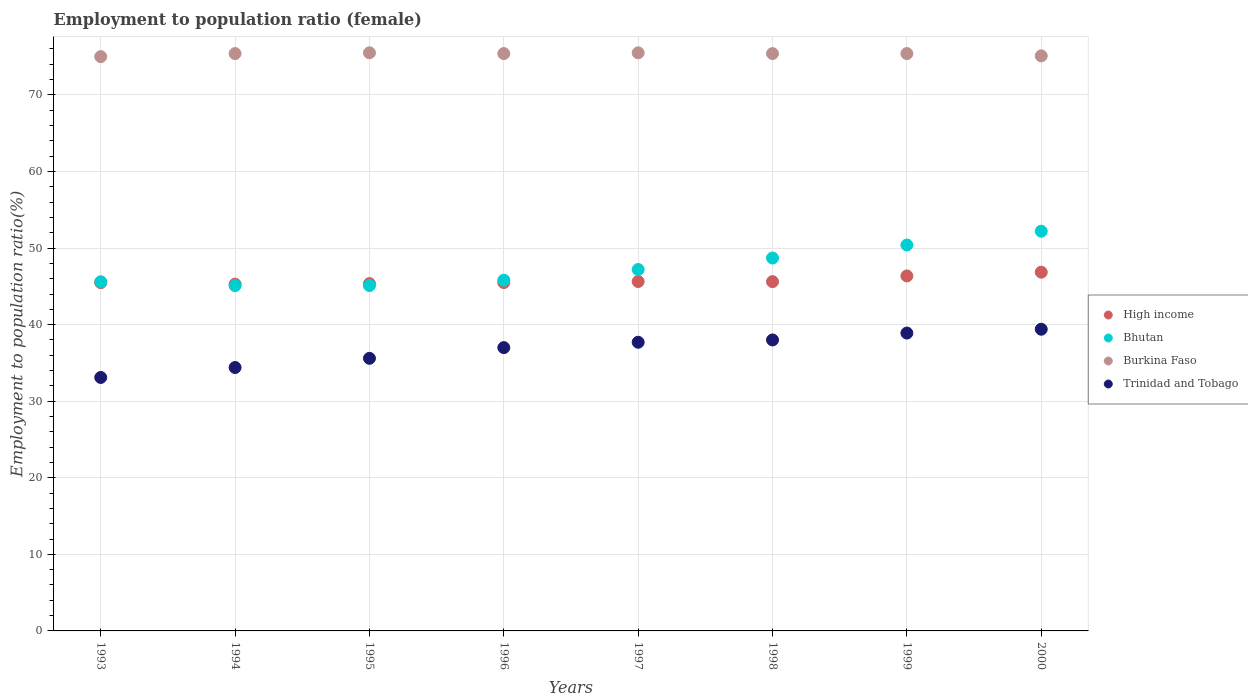Across all years, what is the maximum employment to population ratio in High income?
Give a very brief answer. 46.85. Across all years, what is the minimum employment to population ratio in Trinidad and Tobago?
Ensure brevity in your answer.  33.1. In which year was the employment to population ratio in Trinidad and Tobago maximum?
Provide a succinct answer. 2000. In which year was the employment to population ratio in Burkina Faso minimum?
Keep it short and to the point. 1993. What is the total employment to population ratio in Burkina Faso in the graph?
Offer a very short reply. 602.7. What is the difference between the employment to population ratio in Burkina Faso in 1998 and the employment to population ratio in Bhutan in 1996?
Your response must be concise. 29.6. What is the average employment to population ratio in High income per year?
Give a very brief answer. 45.76. In the year 1999, what is the difference between the employment to population ratio in Trinidad and Tobago and employment to population ratio in High income?
Your answer should be compact. -7.46. What is the ratio of the employment to population ratio in Trinidad and Tobago in 1996 to that in 2000?
Keep it short and to the point. 0.94. Is the employment to population ratio in Bhutan in 1994 less than that in 1998?
Keep it short and to the point. Yes. In how many years, is the employment to population ratio in High income greater than the average employment to population ratio in High income taken over all years?
Provide a succinct answer. 2. Is it the case that in every year, the sum of the employment to population ratio in High income and employment to population ratio in Burkina Faso  is greater than the employment to population ratio in Bhutan?
Give a very brief answer. Yes. Is the employment to population ratio in Bhutan strictly greater than the employment to population ratio in Burkina Faso over the years?
Give a very brief answer. No. How many years are there in the graph?
Provide a succinct answer. 8. Are the values on the major ticks of Y-axis written in scientific E-notation?
Your answer should be very brief. No. Does the graph contain grids?
Keep it short and to the point. Yes. Where does the legend appear in the graph?
Your answer should be compact. Center right. What is the title of the graph?
Your response must be concise. Employment to population ratio (female). Does "Switzerland" appear as one of the legend labels in the graph?
Ensure brevity in your answer.  No. What is the Employment to population ratio(%) in High income in 1993?
Your answer should be compact. 45.48. What is the Employment to population ratio(%) in Bhutan in 1993?
Keep it short and to the point. 45.6. What is the Employment to population ratio(%) in Trinidad and Tobago in 1993?
Ensure brevity in your answer.  33.1. What is the Employment to population ratio(%) in High income in 1994?
Ensure brevity in your answer.  45.29. What is the Employment to population ratio(%) of Bhutan in 1994?
Your answer should be very brief. 45.1. What is the Employment to population ratio(%) in Burkina Faso in 1994?
Offer a terse response. 75.4. What is the Employment to population ratio(%) of Trinidad and Tobago in 1994?
Give a very brief answer. 34.4. What is the Employment to population ratio(%) in High income in 1995?
Give a very brief answer. 45.36. What is the Employment to population ratio(%) of Bhutan in 1995?
Provide a succinct answer. 45.1. What is the Employment to population ratio(%) in Burkina Faso in 1995?
Make the answer very short. 75.5. What is the Employment to population ratio(%) of Trinidad and Tobago in 1995?
Ensure brevity in your answer.  35.6. What is the Employment to population ratio(%) of High income in 1996?
Your answer should be compact. 45.5. What is the Employment to population ratio(%) of Bhutan in 1996?
Your response must be concise. 45.8. What is the Employment to population ratio(%) of Burkina Faso in 1996?
Make the answer very short. 75.4. What is the Employment to population ratio(%) in Trinidad and Tobago in 1996?
Your response must be concise. 37. What is the Employment to population ratio(%) of High income in 1997?
Ensure brevity in your answer.  45.63. What is the Employment to population ratio(%) of Bhutan in 1997?
Your answer should be very brief. 47.2. What is the Employment to population ratio(%) of Burkina Faso in 1997?
Give a very brief answer. 75.5. What is the Employment to population ratio(%) in Trinidad and Tobago in 1997?
Provide a succinct answer. 37.7. What is the Employment to population ratio(%) of High income in 1998?
Keep it short and to the point. 45.61. What is the Employment to population ratio(%) in Bhutan in 1998?
Give a very brief answer. 48.7. What is the Employment to population ratio(%) of Burkina Faso in 1998?
Offer a terse response. 75.4. What is the Employment to population ratio(%) in Trinidad and Tobago in 1998?
Your answer should be very brief. 38. What is the Employment to population ratio(%) in High income in 1999?
Your response must be concise. 46.36. What is the Employment to population ratio(%) of Bhutan in 1999?
Make the answer very short. 50.4. What is the Employment to population ratio(%) of Burkina Faso in 1999?
Provide a succinct answer. 75.4. What is the Employment to population ratio(%) of Trinidad and Tobago in 1999?
Keep it short and to the point. 38.9. What is the Employment to population ratio(%) in High income in 2000?
Offer a very short reply. 46.85. What is the Employment to population ratio(%) in Bhutan in 2000?
Give a very brief answer. 52.2. What is the Employment to population ratio(%) of Burkina Faso in 2000?
Give a very brief answer. 75.1. What is the Employment to population ratio(%) of Trinidad and Tobago in 2000?
Offer a very short reply. 39.4. Across all years, what is the maximum Employment to population ratio(%) in High income?
Your answer should be very brief. 46.85. Across all years, what is the maximum Employment to population ratio(%) in Bhutan?
Offer a very short reply. 52.2. Across all years, what is the maximum Employment to population ratio(%) in Burkina Faso?
Keep it short and to the point. 75.5. Across all years, what is the maximum Employment to population ratio(%) of Trinidad and Tobago?
Your answer should be compact. 39.4. Across all years, what is the minimum Employment to population ratio(%) in High income?
Offer a terse response. 45.29. Across all years, what is the minimum Employment to population ratio(%) of Bhutan?
Your response must be concise. 45.1. Across all years, what is the minimum Employment to population ratio(%) of Trinidad and Tobago?
Ensure brevity in your answer.  33.1. What is the total Employment to population ratio(%) in High income in the graph?
Your answer should be very brief. 366.08. What is the total Employment to population ratio(%) of Bhutan in the graph?
Provide a short and direct response. 380.1. What is the total Employment to population ratio(%) of Burkina Faso in the graph?
Offer a terse response. 602.7. What is the total Employment to population ratio(%) in Trinidad and Tobago in the graph?
Provide a short and direct response. 294.1. What is the difference between the Employment to population ratio(%) of High income in 1993 and that in 1994?
Ensure brevity in your answer.  0.19. What is the difference between the Employment to population ratio(%) in Bhutan in 1993 and that in 1994?
Provide a succinct answer. 0.5. What is the difference between the Employment to population ratio(%) in Trinidad and Tobago in 1993 and that in 1994?
Offer a terse response. -1.3. What is the difference between the Employment to population ratio(%) of High income in 1993 and that in 1995?
Make the answer very short. 0.12. What is the difference between the Employment to population ratio(%) of Bhutan in 1993 and that in 1995?
Offer a terse response. 0.5. What is the difference between the Employment to population ratio(%) of High income in 1993 and that in 1996?
Give a very brief answer. -0.01. What is the difference between the Employment to population ratio(%) of Bhutan in 1993 and that in 1996?
Give a very brief answer. -0.2. What is the difference between the Employment to population ratio(%) of Burkina Faso in 1993 and that in 1996?
Provide a short and direct response. -0.4. What is the difference between the Employment to population ratio(%) in Trinidad and Tobago in 1993 and that in 1996?
Make the answer very short. -3.9. What is the difference between the Employment to population ratio(%) in High income in 1993 and that in 1997?
Keep it short and to the point. -0.15. What is the difference between the Employment to population ratio(%) in Burkina Faso in 1993 and that in 1997?
Ensure brevity in your answer.  -0.5. What is the difference between the Employment to population ratio(%) of Trinidad and Tobago in 1993 and that in 1997?
Keep it short and to the point. -4.6. What is the difference between the Employment to population ratio(%) of High income in 1993 and that in 1998?
Keep it short and to the point. -0.13. What is the difference between the Employment to population ratio(%) of Bhutan in 1993 and that in 1998?
Ensure brevity in your answer.  -3.1. What is the difference between the Employment to population ratio(%) of High income in 1993 and that in 1999?
Ensure brevity in your answer.  -0.88. What is the difference between the Employment to population ratio(%) in Bhutan in 1993 and that in 1999?
Provide a short and direct response. -4.8. What is the difference between the Employment to population ratio(%) in Trinidad and Tobago in 1993 and that in 1999?
Offer a very short reply. -5.8. What is the difference between the Employment to population ratio(%) in High income in 1993 and that in 2000?
Your answer should be very brief. -1.37. What is the difference between the Employment to population ratio(%) of Trinidad and Tobago in 1993 and that in 2000?
Your answer should be very brief. -6.3. What is the difference between the Employment to population ratio(%) of High income in 1994 and that in 1995?
Ensure brevity in your answer.  -0.07. What is the difference between the Employment to population ratio(%) of Bhutan in 1994 and that in 1995?
Keep it short and to the point. 0. What is the difference between the Employment to population ratio(%) of High income in 1994 and that in 1996?
Give a very brief answer. -0.2. What is the difference between the Employment to population ratio(%) of Bhutan in 1994 and that in 1996?
Keep it short and to the point. -0.7. What is the difference between the Employment to population ratio(%) of High income in 1994 and that in 1997?
Give a very brief answer. -0.34. What is the difference between the Employment to population ratio(%) in Burkina Faso in 1994 and that in 1997?
Make the answer very short. -0.1. What is the difference between the Employment to population ratio(%) of High income in 1994 and that in 1998?
Your response must be concise. -0.32. What is the difference between the Employment to population ratio(%) in Burkina Faso in 1994 and that in 1998?
Your answer should be very brief. 0. What is the difference between the Employment to population ratio(%) of Trinidad and Tobago in 1994 and that in 1998?
Your response must be concise. -3.6. What is the difference between the Employment to population ratio(%) of High income in 1994 and that in 1999?
Provide a short and direct response. -1.07. What is the difference between the Employment to population ratio(%) of Burkina Faso in 1994 and that in 1999?
Your response must be concise. 0. What is the difference between the Employment to population ratio(%) in Trinidad and Tobago in 1994 and that in 1999?
Give a very brief answer. -4.5. What is the difference between the Employment to population ratio(%) in High income in 1994 and that in 2000?
Make the answer very short. -1.56. What is the difference between the Employment to population ratio(%) of Bhutan in 1994 and that in 2000?
Offer a terse response. -7.1. What is the difference between the Employment to population ratio(%) in Burkina Faso in 1994 and that in 2000?
Make the answer very short. 0.3. What is the difference between the Employment to population ratio(%) in Trinidad and Tobago in 1994 and that in 2000?
Ensure brevity in your answer.  -5. What is the difference between the Employment to population ratio(%) in High income in 1995 and that in 1996?
Provide a succinct answer. -0.14. What is the difference between the Employment to population ratio(%) in High income in 1995 and that in 1997?
Your answer should be very brief. -0.27. What is the difference between the Employment to population ratio(%) in Burkina Faso in 1995 and that in 1997?
Keep it short and to the point. 0. What is the difference between the Employment to population ratio(%) in High income in 1995 and that in 1998?
Provide a succinct answer. -0.25. What is the difference between the Employment to population ratio(%) in Bhutan in 1995 and that in 1998?
Keep it short and to the point. -3.6. What is the difference between the Employment to population ratio(%) of Trinidad and Tobago in 1995 and that in 1998?
Keep it short and to the point. -2.4. What is the difference between the Employment to population ratio(%) in High income in 1995 and that in 1999?
Offer a very short reply. -1. What is the difference between the Employment to population ratio(%) of Burkina Faso in 1995 and that in 1999?
Your response must be concise. 0.1. What is the difference between the Employment to population ratio(%) in High income in 1995 and that in 2000?
Keep it short and to the point. -1.49. What is the difference between the Employment to population ratio(%) of Burkina Faso in 1995 and that in 2000?
Ensure brevity in your answer.  0.4. What is the difference between the Employment to population ratio(%) of High income in 1996 and that in 1997?
Give a very brief answer. -0.14. What is the difference between the Employment to population ratio(%) in Burkina Faso in 1996 and that in 1997?
Provide a succinct answer. -0.1. What is the difference between the Employment to population ratio(%) of Trinidad and Tobago in 1996 and that in 1997?
Keep it short and to the point. -0.7. What is the difference between the Employment to population ratio(%) in High income in 1996 and that in 1998?
Offer a very short reply. -0.12. What is the difference between the Employment to population ratio(%) in Trinidad and Tobago in 1996 and that in 1998?
Make the answer very short. -1. What is the difference between the Employment to population ratio(%) of High income in 1996 and that in 1999?
Your response must be concise. -0.86. What is the difference between the Employment to population ratio(%) in Trinidad and Tobago in 1996 and that in 1999?
Your answer should be compact. -1.9. What is the difference between the Employment to population ratio(%) in High income in 1996 and that in 2000?
Your answer should be very brief. -1.36. What is the difference between the Employment to population ratio(%) of Burkina Faso in 1996 and that in 2000?
Make the answer very short. 0.3. What is the difference between the Employment to population ratio(%) in Trinidad and Tobago in 1996 and that in 2000?
Give a very brief answer. -2.4. What is the difference between the Employment to population ratio(%) in High income in 1997 and that in 1998?
Ensure brevity in your answer.  0.02. What is the difference between the Employment to population ratio(%) in High income in 1997 and that in 1999?
Keep it short and to the point. -0.73. What is the difference between the Employment to population ratio(%) of High income in 1997 and that in 2000?
Keep it short and to the point. -1.22. What is the difference between the Employment to population ratio(%) in High income in 1998 and that in 1999?
Make the answer very short. -0.75. What is the difference between the Employment to population ratio(%) of Bhutan in 1998 and that in 1999?
Ensure brevity in your answer.  -1.7. What is the difference between the Employment to population ratio(%) in High income in 1998 and that in 2000?
Offer a terse response. -1.24. What is the difference between the Employment to population ratio(%) in High income in 1999 and that in 2000?
Make the answer very short. -0.49. What is the difference between the Employment to population ratio(%) of Bhutan in 1999 and that in 2000?
Keep it short and to the point. -1.8. What is the difference between the Employment to population ratio(%) of Burkina Faso in 1999 and that in 2000?
Keep it short and to the point. 0.3. What is the difference between the Employment to population ratio(%) of Trinidad and Tobago in 1999 and that in 2000?
Provide a succinct answer. -0.5. What is the difference between the Employment to population ratio(%) in High income in 1993 and the Employment to population ratio(%) in Bhutan in 1994?
Provide a short and direct response. 0.38. What is the difference between the Employment to population ratio(%) in High income in 1993 and the Employment to population ratio(%) in Burkina Faso in 1994?
Provide a short and direct response. -29.92. What is the difference between the Employment to population ratio(%) in High income in 1993 and the Employment to population ratio(%) in Trinidad and Tobago in 1994?
Your answer should be very brief. 11.08. What is the difference between the Employment to population ratio(%) in Bhutan in 1993 and the Employment to population ratio(%) in Burkina Faso in 1994?
Give a very brief answer. -29.8. What is the difference between the Employment to population ratio(%) in Burkina Faso in 1993 and the Employment to population ratio(%) in Trinidad and Tobago in 1994?
Provide a succinct answer. 40.6. What is the difference between the Employment to population ratio(%) of High income in 1993 and the Employment to population ratio(%) of Bhutan in 1995?
Offer a very short reply. 0.38. What is the difference between the Employment to population ratio(%) of High income in 1993 and the Employment to population ratio(%) of Burkina Faso in 1995?
Keep it short and to the point. -30.02. What is the difference between the Employment to population ratio(%) in High income in 1993 and the Employment to population ratio(%) in Trinidad and Tobago in 1995?
Provide a succinct answer. 9.88. What is the difference between the Employment to population ratio(%) of Bhutan in 1993 and the Employment to population ratio(%) of Burkina Faso in 1995?
Keep it short and to the point. -29.9. What is the difference between the Employment to population ratio(%) of Bhutan in 1993 and the Employment to population ratio(%) of Trinidad and Tobago in 1995?
Your response must be concise. 10. What is the difference between the Employment to population ratio(%) of Burkina Faso in 1993 and the Employment to population ratio(%) of Trinidad and Tobago in 1995?
Your answer should be compact. 39.4. What is the difference between the Employment to population ratio(%) in High income in 1993 and the Employment to population ratio(%) in Bhutan in 1996?
Your response must be concise. -0.32. What is the difference between the Employment to population ratio(%) in High income in 1993 and the Employment to population ratio(%) in Burkina Faso in 1996?
Your answer should be compact. -29.92. What is the difference between the Employment to population ratio(%) in High income in 1993 and the Employment to population ratio(%) in Trinidad and Tobago in 1996?
Keep it short and to the point. 8.48. What is the difference between the Employment to population ratio(%) of Bhutan in 1993 and the Employment to population ratio(%) of Burkina Faso in 1996?
Give a very brief answer. -29.8. What is the difference between the Employment to population ratio(%) in Bhutan in 1993 and the Employment to population ratio(%) in Trinidad and Tobago in 1996?
Give a very brief answer. 8.6. What is the difference between the Employment to population ratio(%) in Burkina Faso in 1993 and the Employment to population ratio(%) in Trinidad and Tobago in 1996?
Ensure brevity in your answer.  38. What is the difference between the Employment to population ratio(%) of High income in 1993 and the Employment to population ratio(%) of Bhutan in 1997?
Offer a very short reply. -1.72. What is the difference between the Employment to population ratio(%) in High income in 1993 and the Employment to population ratio(%) in Burkina Faso in 1997?
Your answer should be very brief. -30.02. What is the difference between the Employment to population ratio(%) in High income in 1993 and the Employment to population ratio(%) in Trinidad and Tobago in 1997?
Provide a short and direct response. 7.78. What is the difference between the Employment to population ratio(%) in Bhutan in 1993 and the Employment to population ratio(%) in Burkina Faso in 1997?
Your answer should be very brief. -29.9. What is the difference between the Employment to population ratio(%) of Burkina Faso in 1993 and the Employment to population ratio(%) of Trinidad and Tobago in 1997?
Your answer should be very brief. 37.3. What is the difference between the Employment to population ratio(%) of High income in 1993 and the Employment to population ratio(%) of Bhutan in 1998?
Provide a succinct answer. -3.22. What is the difference between the Employment to population ratio(%) in High income in 1993 and the Employment to population ratio(%) in Burkina Faso in 1998?
Give a very brief answer. -29.92. What is the difference between the Employment to population ratio(%) of High income in 1993 and the Employment to population ratio(%) of Trinidad and Tobago in 1998?
Ensure brevity in your answer.  7.48. What is the difference between the Employment to population ratio(%) in Bhutan in 1993 and the Employment to population ratio(%) in Burkina Faso in 1998?
Your answer should be very brief. -29.8. What is the difference between the Employment to population ratio(%) in High income in 1993 and the Employment to population ratio(%) in Bhutan in 1999?
Keep it short and to the point. -4.92. What is the difference between the Employment to population ratio(%) in High income in 1993 and the Employment to population ratio(%) in Burkina Faso in 1999?
Give a very brief answer. -29.92. What is the difference between the Employment to population ratio(%) in High income in 1993 and the Employment to population ratio(%) in Trinidad and Tobago in 1999?
Your response must be concise. 6.58. What is the difference between the Employment to population ratio(%) of Bhutan in 1993 and the Employment to population ratio(%) of Burkina Faso in 1999?
Give a very brief answer. -29.8. What is the difference between the Employment to population ratio(%) of Burkina Faso in 1993 and the Employment to population ratio(%) of Trinidad and Tobago in 1999?
Keep it short and to the point. 36.1. What is the difference between the Employment to population ratio(%) of High income in 1993 and the Employment to population ratio(%) of Bhutan in 2000?
Provide a short and direct response. -6.72. What is the difference between the Employment to population ratio(%) in High income in 1993 and the Employment to population ratio(%) in Burkina Faso in 2000?
Keep it short and to the point. -29.62. What is the difference between the Employment to population ratio(%) in High income in 1993 and the Employment to population ratio(%) in Trinidad and Tobago in 2000?
Your answer should be very brief. 6.08. What is the difference between the Employment to population ratio(%) of Bhutan in 1993 and the Employment to population ratio(%) of Burkina Faso in 2000?
Provide a succinct answer. -29.5. What is the difference between the Employment to population ratio(%) of Bhutan in 1993 and the Employment to population ratio(%) of Trinidad and Tobago in 2000?
Provide a succinct answer. 6.2. What is the difference between the Employment to population ratio(%) in Burkina Faso in 1993 and the Employment to population ratio(%) in Trinidad and Tobago in 2000?
Ensure brevity in your answer.  35.6. What is the difference between the Employment to population ratio(%) in High income in 1994 and the Employment to population ratio(%) in Bhutan in 1995?
Your response must be concise. 0.19. What is the difference between the Employment to population ratio(%) in High income in 1994 and the Employment to population ratio(%) in Burkina Faso in 1995?
Make the answer very short. -30.21. What is the difference between the Employment to population ratio(%) in High income in 1994 and the Employment to population ratio(%) in Trinidad and Tobago in 1995?
Offer a very short reply. 9.69. What is the difference between the Employment to population ratio(%) of Bhutan in 1994 and the Employment to population ratio(%) of Burkina Faso in 1995?
Give a very brief answer. -30.4. What is the difference between the Employment to population ratio(%) in Bhutan in 1994 and the Employment to population ratio(%) in Trinidad and Tobago in 1995?
Your response must be concise. 9.5. What is the difference between the Employment to population ratio(%) in Burkina Faso in 1994 and the Employment to population ratio(%) in Trinidad and Tobago in 1995?
Give a very brief answer. 39.8. What is the difference between the Employment to population ratio(%) of High income in 1994 and the Employment to population ratio(%) of Bhutan in 1996?
Ensure brevity in your answer.  -0.51. What is the difference between the Employment to population ratio(%) in High income in 1994 and the Employment to population ratio(%) in Burkina Faso in 1996?
Your response must be concise. -30.11. What is the difference between the Employment to population ratio(%) of High income in 1994 and the Employment to population ratio(%) of Trinidad and Tobago in 1996?
Ensure brevity in your answer.  8.29. What is the difference between the Employment to population ratio(%) in Bhutan in 1994 and the Employment to population ratio(%) in Burkina Faso in 1996?
Provide a succinct answer. -30.3. What is the difference between the Employment to population ratio(%) in Burkina Faso in 1994 and the Employment to population ratio(%) in Trinidad and Tobago in 1996?
Offer a terse response. 38.4. What is the difference between the Employment to population ratio(%) in High income in 1994 and the Employment to population ratio(%) in Bhutan in 1997?
Ensure brevity in your answer.  -1.91. What is the difference between the Employment to population ratio(%) of High income in 1994 and the Employment to population ratio(%) of Burkina Faso in 1997?
Ensure brevity in your answer.  -30.21. What is the difference between the Employment to population ratio(%) in High income in 1994 and the Employment to population ratio(%) in Trinidad and Tobago in 1997?
Provide a short and direct response. 7.59. What is the difference between the Employment to population ratio(%) in Bhutan in 1994 and the Employment to population ratio(%) in Burkina Faso in 1997?
Keep it short and to the point. -30.4. What is the difference between the Employment to population ratio(%) of Bhutan in 1994 and the Employment to population ratio(%) of Trinidad and Tobago in 1997?
Offer a terse response. 7.4. What is the difference between the Employment to population ratio(%) in Burkina Faso in 1994 and the Employment to population ratio(%) in Trinidad and Tobago in 1997?
Give a very brief answer. 37.7. What is the difference between the Employment to population ratio(%) in High income in 1994 and the Employment to population ratio(%) in Bhutan in 1998?
Your response must be concise. -3.41. What is the difference between the Employment to population ratio(%) of High income in 1994 and the Employment to population ratio(%) of Burkina Faso in 1998?
Offer a terse response. -30.11. What is the difference between the Employment to population ratio(%) of High income in 1994 and the Employment to population ratio(%) of Trinidad and Tobago in 1998?
Make the answer very short. 7.29. What is the difference between the Employment to population ratio(%) in Bhutan in 1994 and the Employment to population ratio(%) in Burkina Faso in 1998?
Keep it short and to the point. -30.3. What is the difference between the Employment to population ratio(%) in Burkina Faso in 1994 and the Employment to population ratio(%) in Trinidad and Tobago in 1998?
Your answer should be compact. 37.4. What is the difference between the Employment to population ratio(%) in High income in 1994 and the Employment to population ratio(%) in Bhutan in 1999?
Provide a succinct answer. -5.11. What is the difference between the Employment to population ratio(%) of High income in 1994 and the Employment to population ratio(%) of Burkina Faso in 1999?
Your answer should be compact. -30.11. What is the difference between the Employment to population ratio(%) in High income in 1994 and the Employment to population ratio(%) in Trinidad and Tobago in 1999?
Give a very brief answer. 6.39. What is the difference between the Employment to population ratio(%) of Bhutan in 1994 and the Employment to population ratio(%) of Burkina Faso in 1999?
Provide a short and direct response. -30.3. What is the difference between the Employment to population ratio(%) of Burkina Faso in 1994 and the Employment to population ratio(%) of Trinidad and Tobago in 1999?
Provide a succinct answer. 36.5. What is the difference between the Employment to population ratio(%) in High income in 1994 and the Employment to population ratio(%) in Bhutan in 2000?
Your response must be concise. -6.91. What is the difference between the Employment to population ratio(%) of High income in 1994 and the Employment to population ratio(%) of Burkina Faso in 2000?
Ensure brevity in your answer.  -29.81. What is the difference between the Employment to population ratio(%) in High income in 1994 and the Employment to population ratio(%) in Trinidad and Tobago in 2000?
Your response must be concise. 5.89. What is the difference between the Employment to population ratio(%) in Bhutan in 1994 and the Employment to population ratio(%) in Trinidad and Tobago in 2000?
Keep it short and to the point. 5.7. What is the difference between the Employment to population ratio(%) of Burkina Faso in 1994 and the Employment to population ratio(%) of Trinidad and Tobago in 2000?
Provide a short and direct response. 36. What is the difference between the Employment to population ratio(%) of High income in 1995 and the Employment to population ratio(%) of Bhutan in 1996?
Provide a short and direct response. -0.44. What is the difference between the Employment to population ratio(%) in High income in 1995 and the Employment to population ratio(%) in Burkina Faso in 1996?
Offer a very short reply. -30.04. What is the difference between the Employment to population ratio(%) of High income in 1995 and the Employment to population ratio(%) of Trinidad and Tobago in 1996?
Ensure brevity in your answer.  8.36. What is the difference between the Employment to population ratio(%) in Bhutan in 1995 and the Employment to population ratio(%) in Burkina Faso in 1996?
Your answer should be very brief. -30.3. What is the difference between the Employment to population ratio(%) of Bhutan in 1995 and the Employment to population ratio(%) of Trinidad and Tobago in 1996?
Ensure brevity in your answer.  8.1. What is the difference between the Employment to population ratio(%) in Burkina Faso in 1995 and the Employment to population ratio(%) in Trinidad and Tobago in 1996?
Your answer should be compact. 38.5. What is the difference between the Employment to population ratio(%) of High income in 1995 and the Employment to population ratio(%) of Bhutan in 1997?
Your answer should be compact. -1.84. What is the difference between the Employment to population ratio(%) of High income in 1995 and the Employment to population ratio(%) of Burkina Faso in 1997?
Make the answer very short. -30.14. What is the difference between the Employment to population ratio(%) of High income in 1995 and the Employment to population ratio(%) of Trinidad and Tobago in 1997?
Keep it short and to the point. 7.66. What is the difference between the Employment to population ratio(%) in Bhutan in 1995 and the Employment to population ratio(%) in Burkina Faso in 1997?
Keep it short and to the point. -30.4. What is the difference between the Employment to population ratio(%) in Burkina Faso in 1995 and the Employment to population ratio(%) in Trinidad and Tobago in 1997?
Give a very brief answer. 37.8. What is the difference between the Employment to population ratio(%) of High income in 1995 and the Employment to population ratio(%) of Bhutan in 1998?
Provide a short and direct response. -3.34. What is the difference between the Employment to population ratio(%) in High income in 1995 and the Employment to population ratio(%) in Burkina Faso in 1998?
Offer a terse response. -30.04. What is the difference between the Employment to population ratio(%) in High income in 1995 and the Employment to population ratio(%) in Trinidad and Tobago in 1998?
Offer a very short reply. 7.36. What is the difference between the Employment to population ratio(%) in Bhutan in 1995 and the Employment to population ratio(%) in Burkina Faso in 1998?
Your answer should be compact. -30.3. What is the difference between the Employment to population ratio(%) of Burkina Faso in 1995 and the Employment to population ratio(%) of Trinidad and Tobago in 1998?
Your answer should be very brief. 37.5. What is the difference between the Employment to population ratio(%) of High income in 1995 and the Employment to population ratio(%) of Bhutan in 1999?
Give a very brief answer. -5.04. What is the difference between the Employment to population ratio(%) of High income in 1995 and the Employment to population ratio(%) of Burkina Faso in 1999?
Provide a short and direct response. -30.04. What is the difference between the Employment to population ratio(%) of High income in 1995 and the Employment to population ratio(%) of Trinidad and Tobago in 1999?
Offer a terse response. 6.46. What is the difference between the Employment to population ratio(%) of Bhutan in 1995 and the Employment to population ratio(%) of Burkina Faso in 1999?
Your answer should be very brief. -30.3. What is the difference between the Employment to population ratio(%) of Burkina Faso in 1995 and the Employment to population ratio(%) of Trinidad and Tobago in 1999?
Provide a succinct answer. 36.6. What is the difference between the Employment to population ratio(%) of High income in 1995 and the Employment to population ratio(%) of Bhutan in 2000?
Keep it short and to the point. -6.84. What is the difference between the Employment to population ratio(%) in High income in 1995 and the Employment to population ratio(%) in Burkina Faso in 2000?
Your answer should be very brief. -29.74. What is the difference between the Employment to population ratio(%) of High income in 1995 and the Employment to population ratio(%) of Trinidad and Tobago in 2000?
Ensure brevity in your answer.  5.96. What is the difference between the Employment to population ratio(%) of Burkina Faso in 1995 and the Employment to population ratio(%) of Trinidad and Tobago in 2000?
Your answer should be very brief. 36.1. What is the difference between the Employment to population ratio(%) of High income in 1996 and the Employment to population ratio(%) of Bhutan in 1997?
Your answer should be compact. -1.7. What is the difference between the Employment to population ratio(%) of High income in 1996 and the Employment to population ratio(%) of Burkina Faso in 1997?
Your answer should be compact. -30. What is the difference between the Employment to population ratio(%) in High income in 1996 and the Employment to population ratio(%) in Trinidad and Tobago in 1997?
Make the answer very short. 7.8. What is the difference between the Employment to population ratio(%) of Bhutan in 1996 and the Employment to population ratio(%) of Burkina Faso in 1997?
Give a very brief answer. -29.7. What is the difference between the Employment to population ratio(%) in Bhutan in 1996 and the Employment to population ratio(%) in Trinidad and Tobago in 1997?
Make the answer very short. 8.1. What is the difference between the Employment to population ratio(%) in Burkina Faso in 1996 and the Employment to population ratio(%) in Trinidad and Tobago in 1997?
Your response must be concise. 37.7. What is the difference between the Employment to population ratio(%) in High income in 1996 and the Employment to population ratio(%) in Bhutan in 1998?
Your response must be concise. -3.2. What is the difference between the Employment to population ratio(%) in High income in 1996 and the Employment to population ratio(%) in Burkina Faso in 1998?
Your answer should be very brief. -29.9. What is the difference between the Employment to population ratio(%) in High income in 1996 and the Employment to population ratio(%) in Trinidad and Tobago in 1998?
Offer a terse response. 7.5. What is the difference between the Employment to population ratio(%) in Bhutan in 1996 and the Employment to population ratio(%) in Burkina Faso in 1998?
Provide a short and direct response. -29.6. What is the difference between the Employment to population ratio(%) in Burkina Faso in 1996 and the Employment to population ratio(%) in Trinidad and Tobago in 1998?
Provide a short and direct response. 37.4. What is the difference between the Employment to population ratio(%) in High income in 1996 and the Employment to population ratio(%) in Bhutan in 1999?
Make the answer very short. -4.9. What is the difference between the Employment to population ratio(%) of High income in 1996 and the Employment to population ratio(%) of Burkina Faso in 1999?
Make the answer very short. -29.9. What is the difference between the Employment to population ratio(%) of High income in 1996 and the Employment to population ratio(%) of Trinidad and Tobago in 1999?
Your response must be concise. 6.6. What is the difference between the Employment to population ratio(%) in Bhutan in 1996 and the Employment to population ratio(%) in Burkina Faso in 1999?
Provide a short and direct response. -29.6. What is the difference between the Employment to population ratio(%) in Burkina Faso in 1996 and the Employment to population ratio(%) in Trinidad and Tobago in 1999?
Provide a succinct answer. 36.5. What is the difference between the Employment to population ratio(%) of High income in 1996 and the Employment to population ratio(%) of Bhutan in 2000?
Your answer should be very brief. -6.7. What is the difference between the Employment to population ratio(%) of High income in 1996 and the Employment to population ratio(%) of Burkina Faso in 2000?
Make the answer very short. -29.6. What is the difference between the Employment to population ratio(%) of High income in 1996 and the Employment to population ratio(%) of Trinidad and Tobago in 2000?
Provide a succinct answer. 6.1. What is the difference between the Employment to population ratio(%) of Bhutan in 1996 and the Employment to population ratio(%) of Burkina Faso in 2000?
Give a very brief answer. -29.3. What is the difference between the Employment to population ratio(%) in Bhutan in 1996 and the Employment to population ratio(%) in Trinidad and Tobago in 2000?
Your answer should be compact. 6.4. What is the difference between the Employment to population ratio(%) in High income in 1997 and the Employment to population ratio(%) in Bhutan in 1998?
Ensure brevity in your answer.  -3.07. What is the difference between the Employment to population ratio(%) in High income in 1997 and the Employment to population ratio(%) in Burkina Faso in 1998?
Provide a succinct answer. -29.77. What is the difference between the Employment to population ratio(%) in High income in 1997 and the Employment to population ratio(%) in Trinidad and Tobago in 1998?
Provide a short and direct response. 7.63. What is the difference between the Employment to population ratio(%) in Bhutan in 1997 and the Employment to population ratio(%) in Burkina Faso in 1998?
Your response must be concise. -28.2. What is the difference between the Employment to population ratio(%) in Burkina Faso in 1997 and the Employment to population ratio(%) in Trinidad and Tobago in 1998?
Make the answer very short. 37.5. What is the difference between the Employment to population ratio(%) of High income in 1997 and the Employment to population ratio(%) of Bhutan in 1999?
Your answer should be very brief. -4.77. What is the difference between the Employment to population ratio(%) in High income in 1997 and the Employment to population ratio(%) in Burkina Faso in 1999?
Your answer should be compact. -29.77. What is the difference between the Employment to population ratio(%) in High income in 1997 and the Employment to population ratio(%) in Trinidad and Tobago in 1999?
Your response must be concise. 6.73. What is the difference between the Employment to population ratio(%) of Bhutan in 1997 and the Employment to population ratio(%) of Burkina Faso in 1999?
Provide a succinct answer. -28.2. What is the difference between the Employment to population ratio(%) of Bhutan in 1997 and the Employment to population ratio(%) of Trinidad and Tobago in 1999?
Your answer should be very brief. 8.3. What is the difference between the Employment to population ratio(%) in Burkina Faso in 1997 and the Employment to population ratio(%) in Trinidad and Tobago in 1999?
Your response must be concise. 36.6. What is the difference between the Employment to population ratio(%) in High income in 1997 and the Employment to population ratio(%) in Bhutan in 2000?
Your answer should be compact. -6.57. What is the difference between the Employment to population ratio(%) of High income in 1997 and the Employment to population ratio(%) of Burkina Faso in 2000?
Give a very brief answer. -29.47. What is the difference between the Employment to population ratio(%) of High income in 1997 and the Employment to population ratio(%) of Trinidad and Tobago in 2000?
Ensure brevity in your answer.  6.23. What is the difference between the Employment to population ratio(%) in Bhutan in 1997 and the Employment to population ratio(%) in Burkina Faso in 2000?
Offer a terse response. -27.9. What is the difference between the Employment to population ratio(%) of Burkina Faso in 1997 and the Employment to population ratio(%) of Trinidad and Tobago in 2000?
Give a very brief answer. 36.1. What is the difference between the Employment to population ratio(%) in High income in 1998 and the Employment to population ratio(%) in Bhutan in 1999?
Your response must be concise. -4.79. What is the difference between the Employment to population ratio(%) of High income in 1998 and the Employment to population ratio(%) of Burkina Faso in 1999?
Keep it short and to the point. -29.79. What is the difference between the Employment to population ratio(%) in High income in 1998 and the Employment to population ratio(%) in Trinidad and Tobago in 1999?
Your response must be concise. 6.71. What is the difference between the Employment to population ratio(%) in Bhutan in 1998 and the Employment to population ratio(%) in Burkina Faso in 1999?
Your answer should be very brief. -26.7. What is the difference between the Employment to population ratio(%) in Burkina Faso in 1998 and the Employment to population ratio(%) in Trinidad and Tobago in 1999?
Your answer should be compact. 36.5. What is the difference between the Employment to population ratio(%) of High income in 1998 and the Employment to population ratio(%) of Bhutan in 2000?
Provide a short and direct response. -6.59. What is the difference between the Employment to population ratio(%) of High income in 1998 and the Employment to population ratio(%) of Burkina Faso in 2000?
Ensure brevity in your answer.  -29.49. What is the difference between the Employment to population ratio(%) of High income in 1998 and the Employment to population ratio(%) of Trinidad and Tobago in 2000?
Keep it short and to the point. 6.21. What is the difference between the Employment to population ratio(%) of Bhutan in 1998 and the Employment to population ratio(%) of Burkina Faso in 2000?
Your response must be concise. -26.4. What is the difference between the Employment to population ratio(%) in High income in 1999 and the Employment to population ratio(%) in Bhutan in 2000?
Offer a terse response. -5.84. What is the difference between the Employment to population ratio(%) of High income in 1999 and the Employment to population ratio(%) of Burkina Faso in 2000?
Give a very brief answer. -28.74. What is the difference between the Employment to population ratio(%) in High income in 1999 and the Employment to population ratio(%) in Trinidad and Tobago in 2000?
Keep it short and to the point. 6.96. What is the difference between the Employment to population ratio(%) in Bhutan in 1999 and the Employment to population ratio(%) in Burkina Faso in 2000?
Your answer should be very brief. -24.7. What is the difference between the Employment to population ratio(%) of Bhutan in 1999 and the Employment to population ratio(%) of Trinidad and Tobago in 2000?
Give a very brief answer. 11. What is the difference between the Employment to population ratio(%) in Burkina Faso in 1999 and the Employment to population ratio(%) in Trinidad and Tobago in 2000?
Offer a very short reply. 36. What is the average Employment to population ratio(%) of High income per year?
Your answer should be compact. 45.76. What is the average Employment to population ratio(%) of Bhutan per year?
Keep it short and to the point. 47.51. What is the average Employment to population ratio(%) of Burkina Faso per year?
Provide a succinct answer. 75.34. What is the average Employment to population ratio(%) of Trinidad and Tobago per year?
Offer a very short reply. 36.76. In the year 1993, what is the difference between the Employment to population ratio(%) of High income and Employment to population ratio(%) of Bhutan?
Provide a short and direct response. -0.12. In the year 1993, what is the difference between the Employment to population ratio(%) in High income and Employment to population ratio(%) in Burkina Faso?
Ensure brevity in your answer.  -29.52. In the year 1993, what is the difference between the Employment to population ratio(%) in High income and Employment to population ratio(%) in Trinidad and Tobago?
Your answer should be very brief. 12.38. In the year 1993, what is the difference between the Employment to population ratio(%) of Bhutan and Employment to population ratio(%) of Burkina Faso?
Your answer should be compact. -29.4. In the year 1993, what is the difference between the Employment to population ratio(%) of Burkina Faso and Employment to population ratio(%) of Trinidad and Tobago?
Give a very brief answer. 41.9. In the year 1994, what is the difference between the Employment to population ratio(%) of High income and Employment to population ratio(%) of Bhutan?
Offer a very short reply. 0.19. In the year 1994, what is the difference between the Employment to population ratio(%) of High income and Employment to population ratio(%) of Burkina Faso?
Your answer should be compact. -30.11. In the year 1994, what is the difference between the Employment to population ratio(%) in High income and Employment to population ratio(%) in Trinidad and Tobago?
Your response must be concise. 10.89. In the year 1994, what is the difference between the Employment to population ratio(%) in Bhutan and Employment to population ratio(%) in Burkina Faso?
Offer a very short reply. -30.3. In the year 1994, what is the difference between the Employment to population ratio(%) in Bhutan and Employment to population ratio(%) in Trinidad and Tobago?
Keep it short and to the point. 10.7. In the year 1994, what is the difference between the Employment to population ratio(%) in Burkina Faso and Employment to population ratio(%) in Trinidad and Tobago?
Make the answer very short. 41. In the year 1995, what is the difference between the Employment to population ratio(%) in High income and Employment to population ratio(%) in Bhutan?
Your answer should be compact. 0.26. In the year 1995, what is the difference between the Employment to population ratio(%) in High income and Employment to population ratio(%) in Burkina Faso?
Your answer should be compact. -30.14. In the year 1995, what is the difference between the Employment to population ratio(%) in High income and Employment to population ratio(%) in Trinidad and Tobago?
Provide a succinct answer. 9.76. In the year 1995, what is the difference between the Employment to population ratio(%) of Bhutan and Employment to population ratio(%) of Burkina Faso?
Keep it short and to the point. -30.4. In the year 1995, what is the difference between the Employment to population ratio(%) of Bhutan and Employment to population ratio(%) of Trinidad and Tobago?
Ensure brevity in your answer.  9.5. In the year 1995, what is the difference between the Employment to population ratio(%) in Burkina Faso and Employment to population ratio(%) in Trinidad and Tobago?
Provide a succinct answer. 39.9. In the year 1996, what is the difference between the Employment to population ratio(%) of High income and Employment to population ratio(%) of Bhutan?
Your response must be concise. -0.3. In the year 1996, what is the difference between the Employment to population ratio(%) in High income and Employment to population ratio(%) in Burkina Faso?
Ensure brevity in your answer.  -29.9. In the year 1996, what is the difference between the Employment to population ratio(%) in High income and Employment to population ratio(%) in Trinidad and Tobago?
Your answer should be very brief. 8.5. In the year 1996, what is the difference between the Employment to population ratio(%) in Bhutan and Employment to population ratio(%) in Burkina Faso?
Offer a terse response. -29.6. In the year 1996, what is the difference between the Employment to population ratio(%) in Bhutan and Employment to population ratio(%) in Trinidad and Tobago?
Offer a terse response. 8.8. In the year 1996, what is the difference between the Employment to population ratio(%) of Burkina Faso and Employment to population ratio(%) of Trinidad and Tobago?
Provide a short and direct response. 38.4. In the year 1997, what is the difference between the Employment to population ratio(%) in High income and Employment to population ratio(%) in Bhutan?
Make the answer very short. -1.57. In the year 1997, what is the difference between the Employment to population ratio(%) of High income and Employment to population ratio(%) of Burkina Faso?
Make the answer very short. -29.87. In the year 1997, what is the difference between the Employment to population ratio(%) of High income and Employment to population ratio(%) of Trinidad and Tobago?
Make the answer very short. 7.93. In the year 1997, what is the difference between the Employment to population ratio(%) in Bhutan and Employment to population ratio(%) in Burkina Faso?
Make the answer very short. -28.3. In the year 1997, what is the difference between the Employment to population ratio(%) in Burkina Faso and Employment to population ratio(%) in Trinidad and Tobago?
Keep it short and to the point. 37.8. In the year 1998, what is the difference between the Employment to population ratio(%) in High income and Employment to population ratio(%) in Bhutan?
Ensure brevity in your answer.  -3.09. In the year 1998, what is the difference between the Employment to population ratio(%) in High income and Employment to population ratio(%) in Burkina Faso?
Provide a short and direct response. -29.79. In the year 1998, what is the difference between the Employment to population ratio(%) in High income and Employment to population ratio(%) in Trinidad and Tobago?
Provide a succinct answer. 7.61. In the year 1998, what is the difference between the Employment to population ratio(%) of Bhutan and Employment to population ratio(%) of Burkina Faso?
Ensure brevity in your answer.  -26.7. In the year 1998, what is the difference between the Employment to population ratio(%) of Bhutan and Employment to population ratio(%) of Trinidad and Tobago?
Your response must be concise. 10.7. In the year 1998, what is the difference between the Employment to population ratio(%) in Burkina Faso and Employment to population ratio(%) in Trinidad and Tobago?
Make the answer very short. 37.4. In the year 1999, what is the difference between the Employment to population ratio(%) in High income and Employment to population ratio(%) in Bhutan?
Make the answer very short. -4.04. In the year 1999, what is the difference between the Employment to population ratio(%) of High income and Employment to population ratio(%) of Burkina Faso?
Provide a succinct answer. -29.04. In the year 1999, what is the difference between the Employment to population ratio(%) of High income and Employment to population ratio(%) of Trinidad and Tobago?
Keep it short and to the point. 7.46. In the year 1999, what is the difference between the Employment to population ratio(%) in Bhutan and Employment to population ratio(%) in Burkina Faso?
Provide a succinct answer. -25. In the year 1999, what is the difference between the Employment to population ratio(%) of Burkina Faso and Employment to population ratio(%) of Trinidad and Tobago?
Offer a terse response. 36.5. In the year 2000, what is the difference between the Employment to population ratio(%) in High income and Employment to population ratio(%) in Bhutan?
Your response must be concise. -5.35. In the year 2000, what is the difference between the Employment to population ratio(%) of High income and Employment to population ratio(%) of Burkina Faso?
Offer a very short reply. -28.25. In the year 2000, what is the difference between the Employment to population ratio(%) in High income and Employment to population ratio(%) in Trinidad and Tobago?
Provide a succinct answer. 7.45. In the year 2000, what is the difference between the Employment to population ratio(%) of Bhutan and Employment to population ratio(%) of Burkina Faso?
Your answer should be very brief. -22.9. In the year 2000, what is the difference between the Employment to population ratio(%) of Bhutan and Employment to population ratio(%) of Trinidad and Tobago?
Give a very brief answer. 12.8. In the year 2000, what is the difference between the Employment to population ratio(%) of Burkina Faso and Employment to population ratio(%) of Trinidad and Tobago?
Your answer should be compact. 35.7. What is the ratio of the Employment to population ratio(%) in High income in 1993 to that in 1994?
Offer a terse response. 1. What is the ratio of the Employment to population ratio(%) of Bhutan in 1993 to that in 1994?
Ensure brevity in your answer.  1.01. What is the ratio of the Employment to population ratio(%) of Trinidad and Tobago in 1993 to that in 1994?
Your answer should be very brief. 0.96. What is the ratio of the Employment to population ratio(%) in High income in 1993 to that in 1995?
Make the answer very short. 1. What is the ratio of the Employment to population ratio(%) in Bhutan in 1993 to that in 1995?
Your response must be concise. 1.01. What is the ratio of the Employment to population ratio(%) in Burkina Faso in 1993 to that in 1995?
Your response must be concise. 0.99. What is the ratio of the Employment to population ratio(%) in Trinidad and Tobago in 1993 to that in 1995?
Your answer should be compact. 0.93. What is the ratio of the Employment to population ratio(%) of Burkina Faso in 1993 to that in 1996?
Ensure brevity in your answer.  0.99. What is the ratio of the Employment to population ratio(%) of Trinidad and Tobago in 1993 to that in 1996?
Provide a short and direct response. 0.89. What is the ratio of the Employment to population ratio(%) of High income in 1993 to that in 1997?
Give a very brief answer. 1. What is the ratio of the Employment to population ratio(%) of Bhutan in 1993 to that in 1997?
Provide a succinct answer. 0.97. What is the ratio of the Employment to population ratio(%) in Trinidad and Tobago in 1993 to that in 1997?
Ensure brevity in your answer.  0.88. What is the ratio of the Employment to population ratio(%) in Bhutan in 1993 to that in 1998?
Make the answer very short. 0.94. What is the ratio of the Employment to population ratio(%) in Burkina Faso in 1993 to that in 1998?
Make the answer very short. 0.99. What is the ratio of the Employment to population ratio(%) of Trinidad and Tobago in 1993 to that in 1998?
Provide a succinct answer. 0.87. What is the ratio of the Employment to population ratio(%) of High income in 1993 to that in 1999?
Keep it short and to the point. 0.98. What is the ratio of the Employment to population ratio(%) of Bhutan in 1993 to that in 1999?
Your answer should be compact. 0.9. What is the ratio of the Employment to population ratio(%) of Trinidad and Tobago in 1993 to that in 1999?
Keep it short and to the point. 0.85. What is the ratio of the Employment to population ratio(%) in High income in 1993 to that in 2000?
Your answer should be compact. 0.97. What is the ratio of the Employment to population ratio(%) in Bhutan in 1993 to that in 2000?
Ensure brevity in your answer.  0.87. What is the ratio of the Employment to population ratio(%) in Trinidad and Tobago in 1993 to that in 2000?
Your answer should be compact. 0.84. What is the ratio of the Employment to population ratio(%) of Bhutan in 1994 to that in 1995?
Provide a succinct answer. 1. What is the ratio of the Employment to population ratio(%) in Burkina Faso in 1994 to that in 1995?
Make the answer very short. 1. What is the ratio of the Employment to population ratio(%) of Trinidad and Tobago in 1994 to that in 1995?
Your answer should be compact. 0.97. What is the ratio of the Employment to population ratio(%) in High income in 1994 to that in 1996?
Your answer should be very brief. 1. What is the ratio of the Employment to population ratio(%) of Bhutan in 1994 to that in 1996?
Keep it short and to the point. 0.98. What is the ratio of the Employment to population ratio(%) of Trinidad and Tobago in 1994 to that in 1996?
Your answer should be compact. 0.93. What is the ratio of the Employment to population ratio(%) of Bhutan in 1994 to that in 1997?
Make the answer very short. 0.96. What is the ratio of the Employment to population ratio(%) of Burkina Faso in 1994 to that in 1997?
Provide a succinct answer. 1. What is the ratio of the Employment to population ratio(%) of Trinidad and Tobago in 1994 to that in 1997?
Ensure brevity in your answer.  0.91. What is the ratio of the Employment to population ratio(%) in High income in 1994 to that in 1998?
Keep it short and to the point. 0.99. What is the ratio of the Employment to population ratio(%) in Bhutan in 1994 to that in 1998?
Your response must be concise. 0.93. What is the ratio of the Employment to population ratio(%) in Trinidad and Tobago in 1994 to that in 1998?
Your answer should be compact. 0.91. What is the ratio of the Employment to population ratio(%) of High income in 1994 to that in 1999?
Give a very brief answer. 0.98. What is the ratio of the Employment to population ratio(%) of Bhutan in 1994 to that in 1999?
Keep it short and to the point. 0.89. What is the ratio of the Employment to population ratio(%) in Trinidad and Tobago in 1994 to that in 1999?
Ensure brevity in your answer.  0.88. What is the ratio of the Employment to population ratio(%) of High income in 1994 to that in 2000?
Ensure brevity in your answer.  0.97. What is the ratio of the Employment to population ratio(%) of Bhutan in 1994 to that in 2000?
Offer a terse response. 0.86. What is the ratio of the Employment to population ratio(%) in Burkina Faso in 1994 to that in 2000?
Your response must be concise. 1. What is the ratio of the Employment to population ratio(%) of Trinidad and Tobago in 1994 to that in 2000?
Your answer should be very brief. 0.87. What is the ratio of the Employment to population ratio(%) of Bhutan in 1995 to that in 1996?
Make the answer very short. 0.98. What is the ratio of the Employment to population ratio(%) in Burkina Faso in 1995 to that in 1996?
Give a very brief answer. 1. What is the ratio of the Employment to population ratio(%) in Trinidad and Tobago in 1995 to that in 1996?
Your answer should be compact. 0.96. What is the ratio of the Employment to population ratio(%) of Bhutan in 1995 to that in 1997?
Your answer should be compact. 0.96. What is the ratio of the Employment to population ratio(%) of Trinidad and Tobago in 1995 to that in 1997?
Your response must be concise. 0.94. What is the ratio of the Employment to population ratio(%) of High income in 1995 to that in 1998?
Provide a succinct answer. 0.99. What is the ratio of the Employment to population ratio(%) in Bhutan in 1995 to that in 1998?
Your response must be concise. 0.93. What is the ratio of the Employment to population ratio(%) of Trinidad and Tobago in 1995 to that in 1998?
Keep it short and to the point. 0.94. What is the ratio of the Employment to population ratio(%) of High income in 1995 to that in 1999?
Keep it short and to the point. 0.98. What is the ratio of the Employment to population ratio(%) in Bhutan in 1995 to that in 1999?
Provide a succinct answer. 0.89. What is the ratio of the Employment to population ratio(%) in Burkina Faso in 1995 to that in 1999?
Ensure brevity in your answer.  1. What is the ratio of the Employment to population ratio(%) in Trinidad and Tobago in 1995 to that in 1999?
Your answer should be very brief. 0.92. What is the ratio of the Employment to population ratio(%) in High income in 1995 to that in 2000?
Your answer should be very brief. 0.97. What is the ratio of the Employment to population ratio(%) of Bhutan in 1995 to that in 2000?
Provide a succinct answer. 0.86. What is the ratio of the Employment to population ratio(%) of Trinidad and Tobago in 1995 to that in 2000?
Give a very brief answer. 0.9. What is the ratio of the Employment to population ratio(%) in Bhutan in 1996 to that in 1997?
Give a very brief answer. 0.97. What is the ratio of the Employment to population ratio(%) in Burkina Faso in 1996 to that in 1997?
Offer a very short reply. 1. What is the ratio of the Employment to population ratio(%) in Trinidad and Tobago in 1996 to that in 1997?
Offer a terse response. 0.98. What is the ratio of the Employment to population ratio(%) in Bhutan in 1996 to that in 1998?
Your answer should be compact. 0.94. What is the ratio of the Employment to population ratio(%) in Burkina Faso in 1996 to that in 1998?
Ensure brevity in your answer.  1. What is the ratio of the Employment to population ratio(%) in Trinidad and Tobago in 1996 to that in 1998?
Keep it short and to the point. 0.97. What is the ratio of the Employment to population ratio(%) in High income in 1996 to that in 1999?
Ensure brevity in your answer.  0.98. What is the ratio of the Employment to population ratio(%) of Bhutan in 1996 to that in 1999?
Ensure brevity in your answer.  0.91. What is the ratio of the Employment to population ratio(%) in Burkina Faso in 1996 to that in 1999?
Offer a very short reply. 1. What is the ratio of the Employment to population ratio(%) in Trinidad and Tobago in 1996 to that in 1999?
Ensure brevity in your answer.  0.95. What is the ratio of the Employment to population ratio(%) in High income in 1996 to that in 2000?
Offer a very short reply. 0.97. What is the ratio of the Employment to population ratio(%) in Bhutan in 1996 to that in 2000?
Make the answer very short. 0.88. What is the ratio of the Employment to population ratio(%) of Burkina Faso in 1996 to that in 2000?
Your answer should be compact. 1. What is the ratio of the Employment to population ratio(%) of Trinidad and Tobago in 1996 to that in 2000?
Offer a very short reply. 0.94. What is the ratio of the Employment to population ratio(%) in High income in 1997 to that in 1998?
Your answer should be compact. 1. What is the ratio of the Employment to population ratio(%) in Bhutan in 1997 to that in 1998?
Give a very brief answer. 0.97. What is the ratio of the Employment to population ratio(%) in Trinidad and Tobago in 1997 to that in 1998?
Provide a succinct answer. 0.99. What is the ratio of the Employment to population ratio(%) of High income in 1997 to that in 1999?
Give a very brief answer. 0.98. What is the ratio of the Employment to population ratio(%) of Bhutan in 1997 to that in 1999?
Offer a very short reply. 0.94. What is the ratio of the Employment to population ratio(%) in Trinidad and Tobago in 1997 to that in 1999?
Make the answer very short. 0.97. What is the ratio of the Employment to population ratio(%) in High income in 1997 to that in 2000?
Your response must be concise. 0.97. What is the ratio of the Employment to population ratio(%) in Bhutan in 1997 to that in 2000?
Provide a short and direct response. 0.9. What is the ratio of the Employment to population ratio(%) of Burkina Faso in 1997 to that in 2000?
Keep it short and to the point. 1.01. What is the ratio of the Employment to population ratio(%) of Trinidad and Tobago in 1997 to that in 2000?
Offer a very short reply. 0.96. What is the ratio of the Employment to population ratio(%) of High income in 1998 to that in 1999?
Ensure brevity in your answer.  0.98. What is the ratio of the Employment to population ratio(%) of Bhutan in 1998 to that in 1999?
Give a very brief answer. 0.97. What is the ratio of the Employment to population ratio(%) in Trinidad and Tobago in 1998 to that in 1999?
Provide a succinct answer. 0.98. What is the ratio of the Employment to population ratio(%) in High income in 1998 to that in 2000?
Make the answer very short. 0.97. What is the ratio of the Employment to population ratio(%) of Bhutan in 1998 to that in 2000?
Offer a terse response. 0.93. What is the ratio of the Employment to population ratio(%) of Trinidad and Tobago in 1998 to that in 2000?
Give a very brief answer. 0.96. What is the ratio of the Employment to population ratio(%) in High income in 1999 to that in 2000?
Make the answer very short. 0.99. What is the ratio of the Employment to population ratio(%) of Bhutan in 1999 to that in 2000?
Make the answer very short. 0.97. What is the ratio of the Employment to population ratio(%) of Burkina Faso in 1999 to that in 2000?
Provide a short and direct response. 1. What is the ratio of the Employment to population ratio(%) of Trinidad and Tobago in 1999 to that in 2000?
Offer a very short reply. 0.99. What is the difference between the highest and the second highest Employment to population ratio(%) of High income?
Offer a very short reply. 0.49. What is the difference between the highest and the second highest Employment to population ratio(%) in Bhutan?
Give a very brief answer. 1.8. What is the difference between the highest and the second highest Employment to population ratio(%) in Burkina Faso?
Provide a short and direct response. 0. What is the difference between the highest and the second highest Employment to population ratio(%) of Trinidad and Tobago?
Your response must be concise. 0.5. What is the difference between the highest and the lowest Employment to population ratio(%) of High income?
Your answer should be compact. 1.56. 